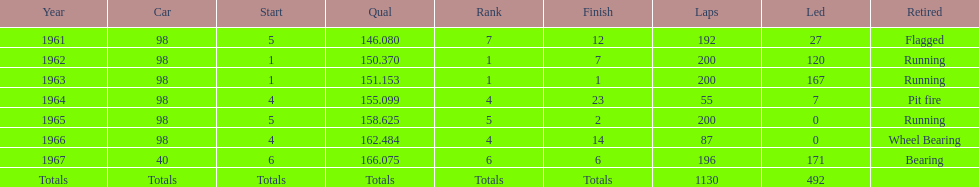What is the difference between the qualfying time in 1967 and 1965? 7.45. 